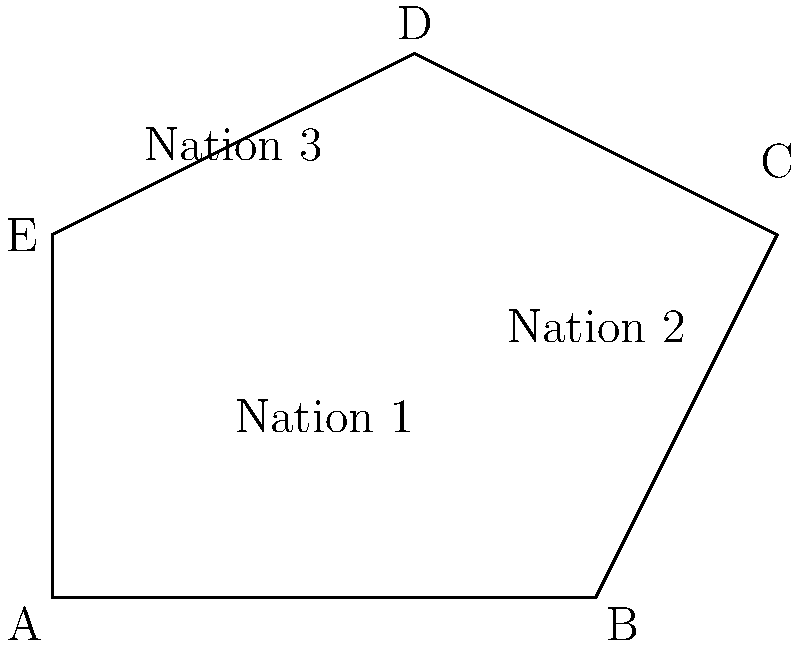As a retired diplomat, you're analyzing a map of allied nations. The map shows a polygonal region formed by five key cities (A, B, C, D, and E) representing the borders of three allied nations. Given the coordinates of these cities: A(0,0), B(6,0), C(8,4), D(4,6), and E(0,4), calculate the total area of the region formed by these allied nations. To calculate the area of this polygonal region, we can use the Shoelace formula (also known as the surveyor's formula). The steps are as follows:

1) The Shoelace formula for a polygon with vertices $(x_1, y_1), (x_2, y_2), ..., (x_n, y_n)$ is:

   Area = $\frac{1}{2}|((x_1y_2 + x_2y_3 + ... + x_ny_1) - (y_1x_2 + y_2x_3 + ... + y_nx_1))|$

2) In our case, we have:
   A(0,0), B(6,0), C(8,4), D(4,6), E(0,4)

3) Let's apply the formula:

   $\frac{1}{2}|((0 \cdot 0 + 6 \cdot 4 + 8 \cdot 6 + 4 \cdot 4 + 0 \cdot 0) - (0 \cdot 6 + 0 \cdot 8 + 4 \cdot 4 + 6 \cdot 0 + 4 \cdot 0))|$

4) Simplify:

   $\frac{1}{2}|((0 + 24 + 48 + 16 + 0) - (0 + 0 + 16 + 0 + 0))|$

5) Calculate:

   $\frac{1}{2}|(88 - 16)|$

   $\frac{1}{2}(72)$

   $36$

Thus, the area of the polygonal region is 36 square units.
Answer: 36 square units 